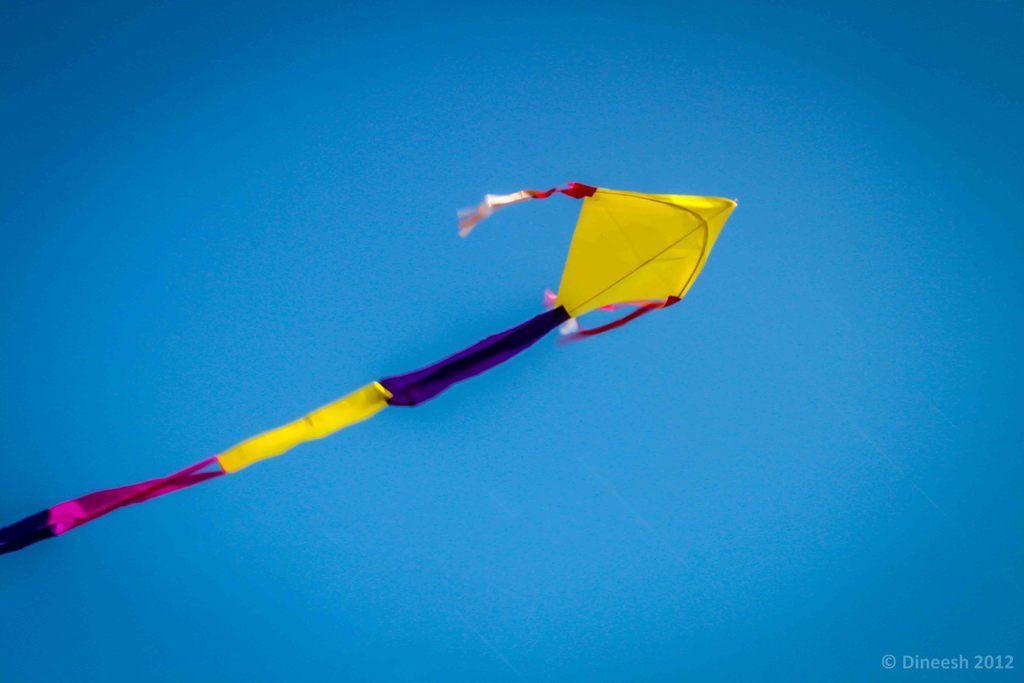How would you summarize this image in a sentence or two? In this image we can see one colorful kite in the blue sky and on the right side of the image there is some text. 